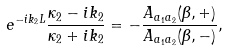<formula> <loc_0><loc_0><loc_500><loc_500>e ^ { - i k _ { 2 } L } \frac { \kappa _ { 2 } - i k _ { 2 } } { \kappa _ { 2 } + i k _ { 2 } } = - \frac { A _ { a _ { 1 } a _ { 2 } } ( \beta , + ) } { A _ { a _ { 1 } a _ { 2 } } ( \beta , - ) } ,</formula> 